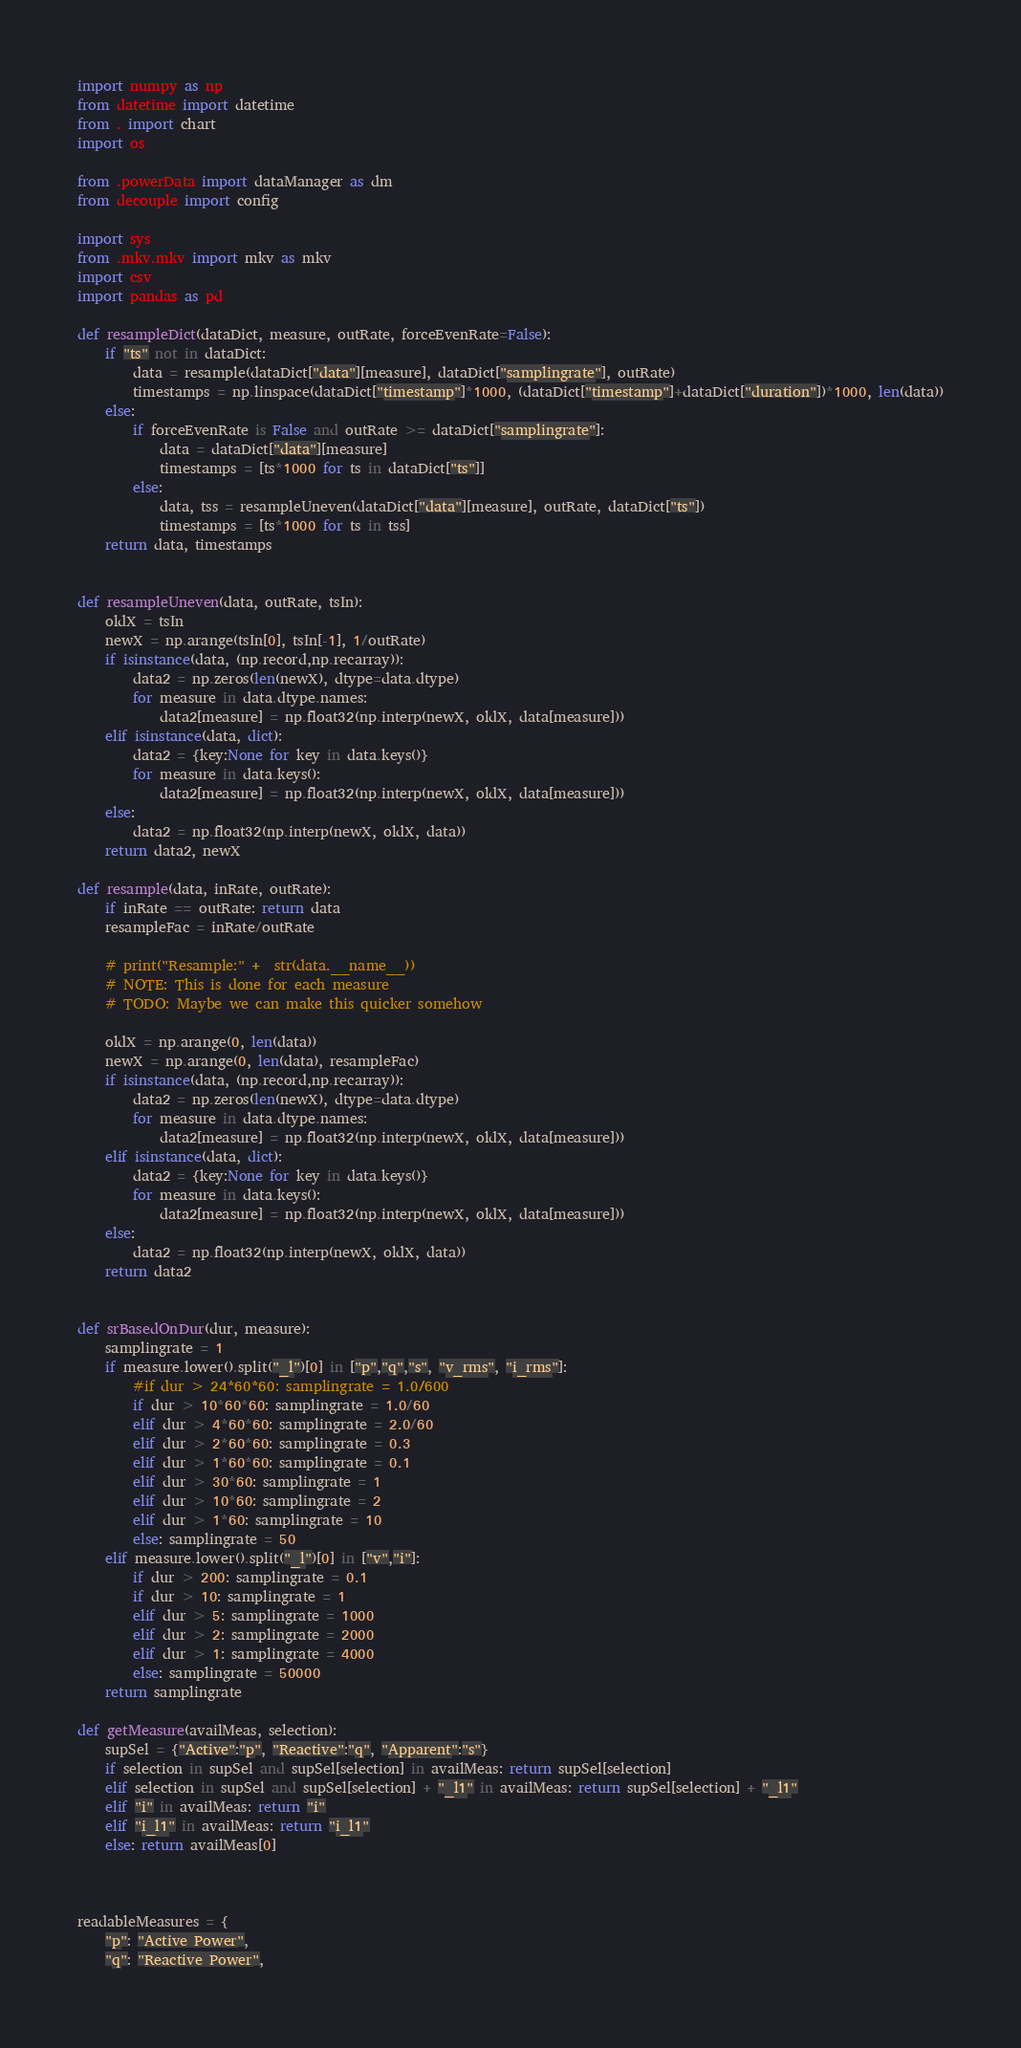<code> <loc_0><loc_0><loc_500><loc_500><_Python_>import numpy as np
from datetime import datetime
from . import chart
import os

from .powerData import dataManager as dm
from decouple import config

import sys
from .mkv.mkv import mkv as mkv
import csv
import pandas as pd

def resampleDict(dataDict, measure, outRate, forceEvenRate=False):
    if "ts" not in dataDict: 
        data = resample(dataDict["data"][measure], dataDict["samplingrate"], outRate) 
        timestamps = np.linspace(dataDict["timestamp"]*1000, (dataDict["timestamp"]+dataDict["duration"])*1000, len(data))
    else:
        if forceEvenRate is False and outRate >= dataDict["samplingrate"]:
            data = dataDict["data"][measure] 
            timestamps = [ts*1000 for ts in dataDict["ts"]]
        else:
            data, tss = resampleUneven(dataDict["data"][measure], outRate, dataDict["ts"]) 
            timestamps = [ts*1000 for ts in tss]
    return data, timestamps


def resampleUneven(data, outRate, tsIn):
    oldX = tsIn
    newX = np.arange(tsIn[0], tsIn[-1], 1/outRate)
    if isinstance(data, (np.record,np.recarray)):
        data2 = np.zeros(len(newX), dtype=data.dtype)
        for measure in data.dtype.names:
            data2[measure] = np.float32(np.interp(newX, oldX, data[measure]))
    elif isinstance(data, dict):
        data2 = {key:None for key in data.keys()}
        for measure in data.keys():
            data2[measure] = np.float32(np.interp(newX, oldX, data[measure]))
    else:
        data2 = np.float32(np.interp(newX, oldX, data))
    return data2, newX

def resample(data, inRate, outRate):
    if inRate == outRate: return data
    resampleFac = inRate/outRate

    # print("Resample:" +  str(data.__name__))
    # NOTE: This is done for each measure
    # TODO: Maybe we can make this quicker somehow
    
    oldX = np.arange(0, len(data))
    newX = np.arange(0, len(data), resampleFac)
    if isinstance(data, (np.record,np.recarray)):
        data2 = np.zeros(len(newX), dtype=data.dtype)
        for measure in data.dtype.names:
            data2[measure] = np.float32(np.interp(newX, oldX, data[measure]))
    elif isinstance(data, dict):
        data2 = {key:None for key in data.keys()}
        for measure in data.keys():
            data2[measure] = np.float32(np.interp(newX, oldX, data[measure]))
    else:
        data2 = np.float32(np.interp(newX, oldX, data))
    return data2


def srBasedOnDur(dur, measure):
    samplingrate = 1
    if measure.lower().split("_l")[0] in ["p","q","s", "v_rms", "i_rms"]:
        #if dur > 24*60*60: samplingrate = 1.0/600
        if dur > 10*60*60: samplingrate = 1.0/60
        elif dur > 4*60*60: samplingrate = 2.0/60
        elif dur > 2*60*60: samplingrate = 0.3
        elif dur > 1*60*60: samplingrate = 0.1
        elif dur > 30*60: samplingrate = 1
        elif dur > 10*60: samplingrate = 2
        elif dur > 1*60: samplingrate = 10
        else: samplingrate = 50
    elif measure.lower().split("_l")[0] in ["v","i"]:
        if dur > 200: samplingrate = 0.1
        if dur > 10: samplingrate = 1
        elif dur > 5: samplingrate = 1000
        elif dur > 2: samplingrate = 2000
        elif dur > 1: samplingrate = 4000
        else: samplingrate = 50000
    return samplingrate

def getMeasure(availMeas, selection):
    supSel = {"Active":"p", "Reactive":"q", "Apparent":"s"}
    if selection in supSel and supSel[selection] in availMeas: return supSel[selection]
    elif selection in supSel and supSel[selection] + "_l1" in availMeas: return supSel[selection] + "_l1"
    elif "i" in availMeas: return "i"
    elif "i_l1" in availMeas: return "i_l1"
    else: return availMeas[0]



readableMeasures = {
    "p": "Active Power",
    "q": "Reactive Power",</code> 